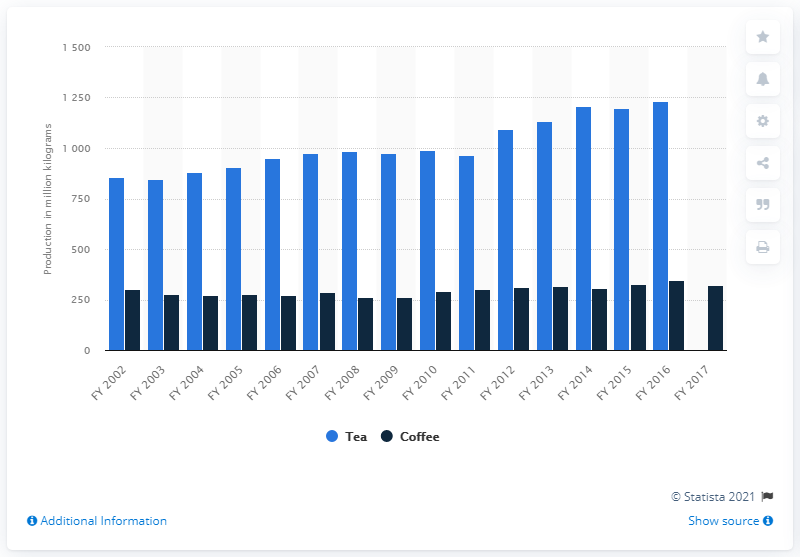Identify some key points in this picture. In the fiscal year 2017, a total of 320 million kg of coffee was produced in India. 